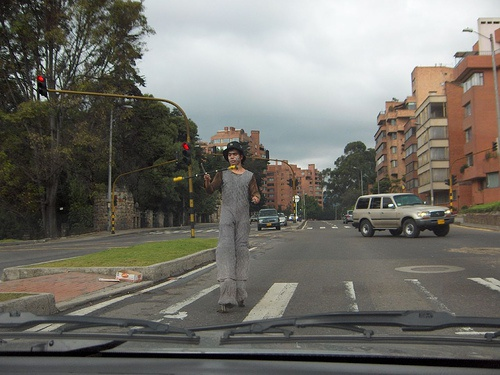Describe the objects in this image and their specific colors. I can see people in black and gray tones, car in black, gray, and darkgray tones, truck in black, gray, purple, and darkgray tones, traffic light in black, maroon, red, and brown tones, and traffic light in black, maroon, red, and gray tones in this image. 